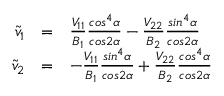Convert formula to latex. <formula><loc_0><loc_0><loc_500><loc_500>\begin{array} { r c l } { { \tilde { v } _ { 1 } } } & { = } & { { { \frac { V _ { 1 1 } } { B _ { 1 } } } { \frac { \cos ^ { 4 } \alpha } { \cos 2 \alpha } } - { \frac { V _ { 2 2 } } { B _ { 2 } } } { \frac { \sin ^ { 4 } \alpha } { \cos 2 \alpha } } } } \\ { { \tilde { v } _ { 2 } } } & { = } & { { - { \frac { V _ { 1 1 } } { B _ { 1 } } } { \frac { \sin ^ { 4 } \alpha } { \cos 2 \alpha } } + { \frac { V _ { 2 2 } } { B _ { 2 } } } { \frac { \cos ^ { 4 } \alpha } { \cos 2 \alpha } } } } \end{array}</formula> 